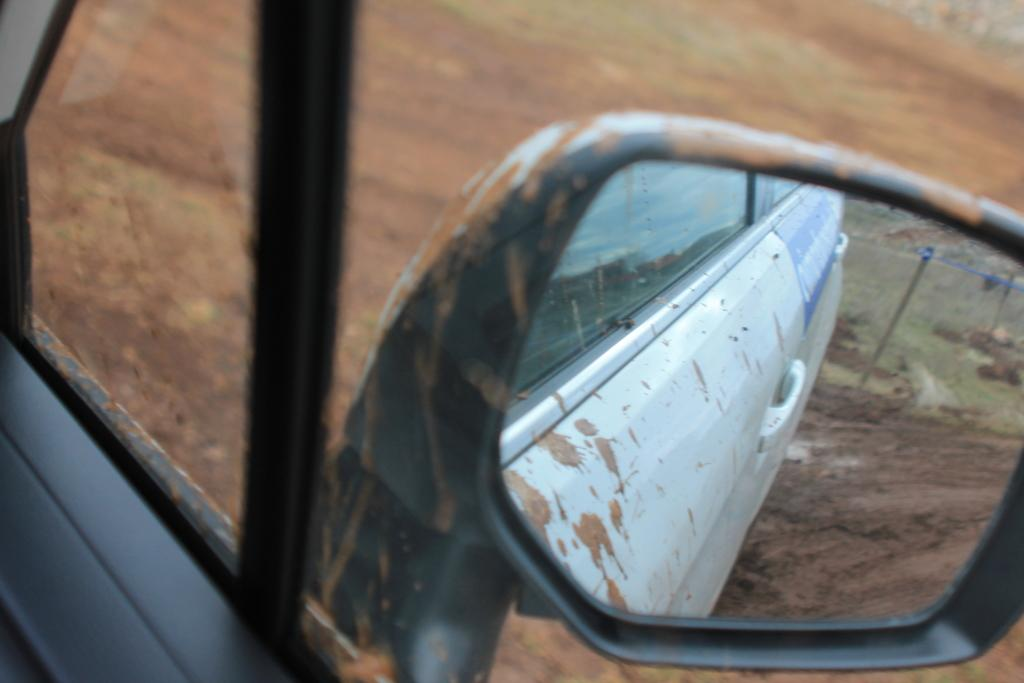What object is the main focus of the image? The main object in the image is a vehicle side mirror. What does the side mirror reflect in the image? The side mirror reflects a vehicle door, a path, and a pole in the image. What type of quince is being used to fan the stamp in the image? There is no quince, fan, or stamp present in the image. 